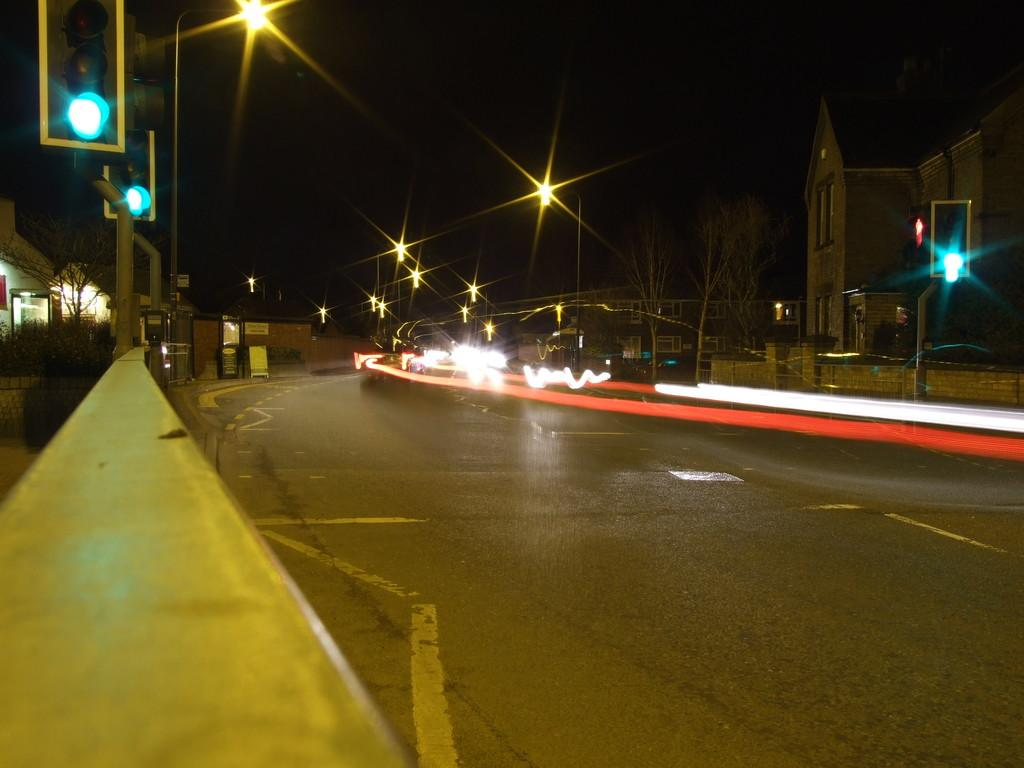What is the main feature of the image? There is a road in the image. What can be seen on the left side of the road? There are traffic poles on the left side of the road. What is located to the right of the road? There is a building to the right of the road. What is visible at the top of the image? The sky is visible at the top of the image. Is there an island visible in the image? No, there is no island present in the image. What type of question is being asked in the image? There is no question being asked in the image; it is a visual representation of a road, traffic poles, a building, and the sky. 